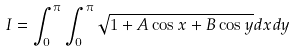<formula> <loc_0><loc_0><loc_500><loc_500>I = \int _ { 0 } ^ { \pi } \int _ { 0 } ^ { \pi } \sqrt { 1 + A \cos x + B \cos y } d x d y</formula> 